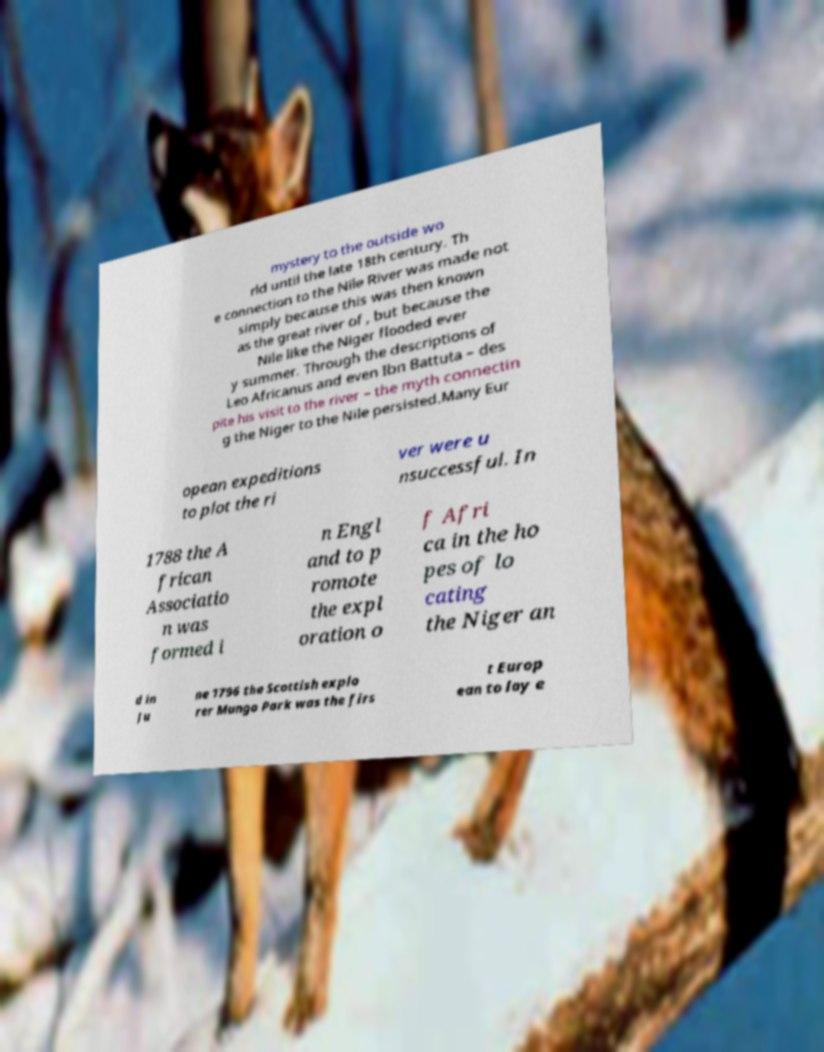Can you accurately transcribe the text from the provided image for me? mystery to the outside wo rld until the late 18th century. Th e connection to the Nile River was made not simply because this was then known as the great river of , but because the Nile like the Niger flooded ever y summer. Through the descriptions of Leo Africanus and even Ibn Battuta – des pite his visit to the river – the myth connectin g the Niger to the Nile persisted.Many Eur opean expeditions to plot the ri ver were u nsuccessful. In 1788 the A frican Associatio n was formed i n Engl and to p romote the expl oration o f Afri ca in the ho pes of lo cating the Niger an d in Ju ne 1796 the Scottish explo rer Mungo Park was the firs t Europ ean to lay e 